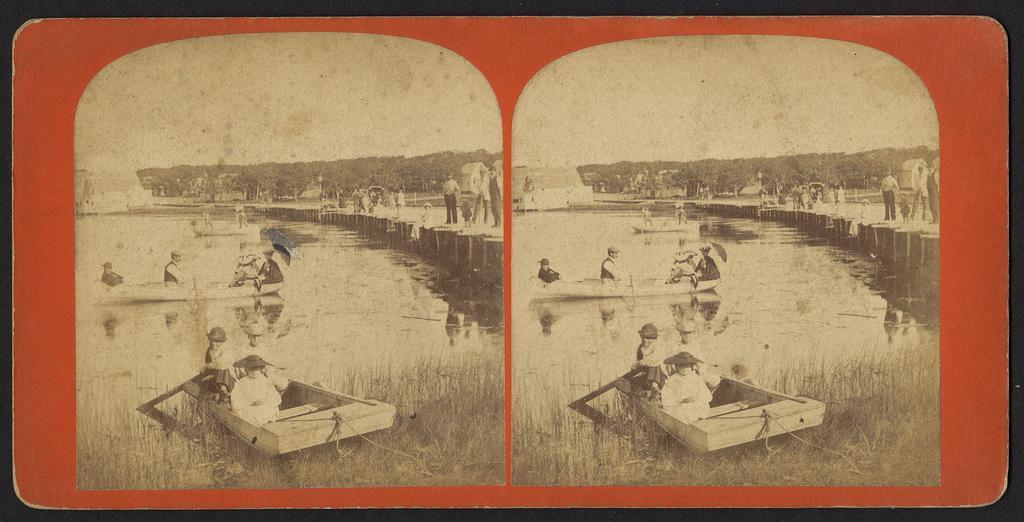In one or two sentences, can you explain what this image depicts? This is a collage of the same pictures, in which there are some people in the boats and also we can see a bridge on which there are some people. We can see some plants and grass. 